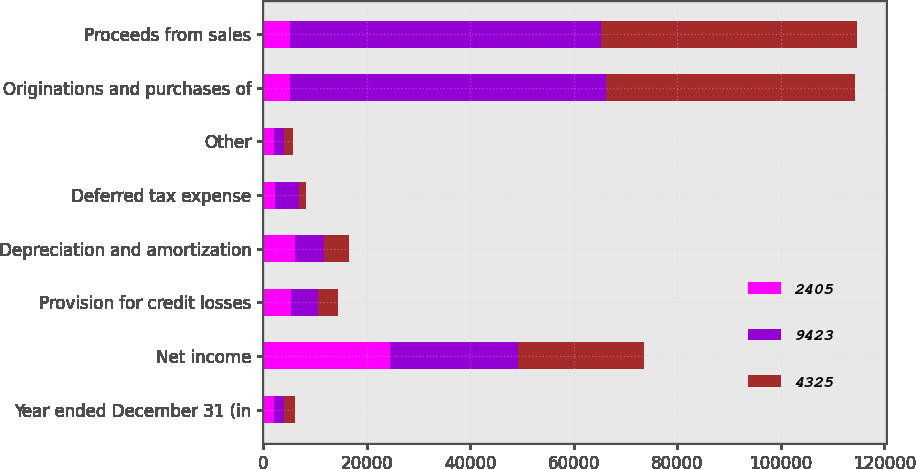Convert chart to OTSL. <chart><loc_0><loc_0><loc_500><loc_500><stacked_bar_chart><ecel><fcel>Year ended December 31 (in<fcel>Net income<fcel>Provision for credit losses<fcel>Depreciation and amortization<fcel>Deferred tax expense<fcel>Other<fcel>Originations and purchases of<fcel>Proceeds from sales<nl><fcel>2405<fcel>2017<fcel>24441<fcel>5290<fcel>6179<fcel>2312<fcel>2136<fcel>5115<fcel>5115<nl><fcel>9423<fcel>2016<fcel>24733<fcel>5361<fcel>5478<fcel>4651<fcel>1799<fcel>61107<fcel>60196<nl><fcel>4325<fcel>2015<fcel>24442<fcel>3827<fcel>4940<fcel>1333<fcel>1785<fcel>48109<fcel>49363<nl></chart> 